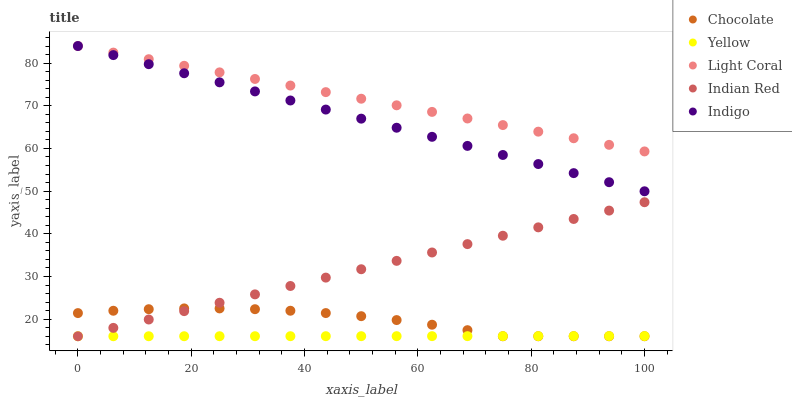Does Yellow have the minimum area under the curve?
Answer yes or no. Yes. Does Light Coral have the maximum area under the curve?
Answer yes or no. Yes. Does Indigo have the minimum area under the curve?
Answer yes or no. No. Does Indigo have the maximum area under the curve?
Answer yes or no. No. Is Yellow the smoothest?
Answer yes or no. Yes. Is Chocolate the roughest?
Answer yes or no. Yes. Is Indigo the smoothest?
Answer yes or no. No. Is Indigo the roughest?
Answer yes or no. No. Does Indian Red have the lowest value?
Answer yes or no. Yes. Does Indigo have the lowest value?
Answer yes or no. No. Does Indigo have the highest value?
Answer yes or no. Yes. Does Indian Red have the highest value?
Answer yes or no. No. Is Chocolate less than Indigo?
Answer yes or no. Yes. Is Indigo greater than Chocolate?
Answer yes or no. Yes. Does Indian Red intersect Chocolate?
Answer yes or no. Yes. Is Indian Red less than Chocolate?
Answer yes or no. No. Is Indian Red greater than Chocolate?
Answer yes or no. No. Does Chocolate intersect Indigo?
Answer yes or no. No. 